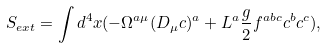Convert formula to latex. <formula><loc_0><loc_0><loc_500><loc_500>S _ { e x t } = \int d ^ { 4 } x ( - \Omega ^ { a \mu } ( D _ { \mu } c ) ^ { a } + L ^ { a } \frac { g } { 2 } f ^ { a b c } c ^ { b } c ^ { c } ) ,</formula> 